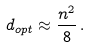Convert formula to latex. <formula><loc_0><loc_0><loc_500><loc_500>d _ { o p t } \approx \frac { n ^ { 2 } } { 8 } \, .</formula> 